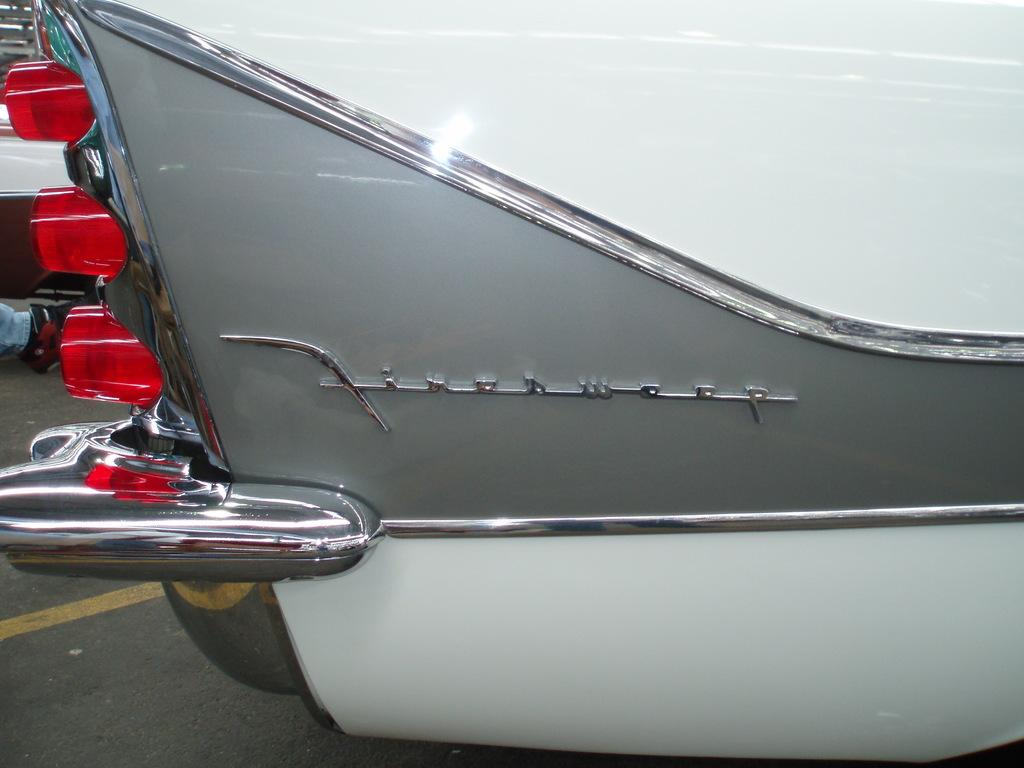What is the main subject of the image? The main subject of the image is a car. What specific feature can be seen on the car? The car has tail lights. What colors are the car in the image? The car is in white and gray colors. What type of tooth can be seen in the image? There is no tooth present in the image; it features a car. What kind of pie is being served in the image? There is no pie present in the image; it features a car. 